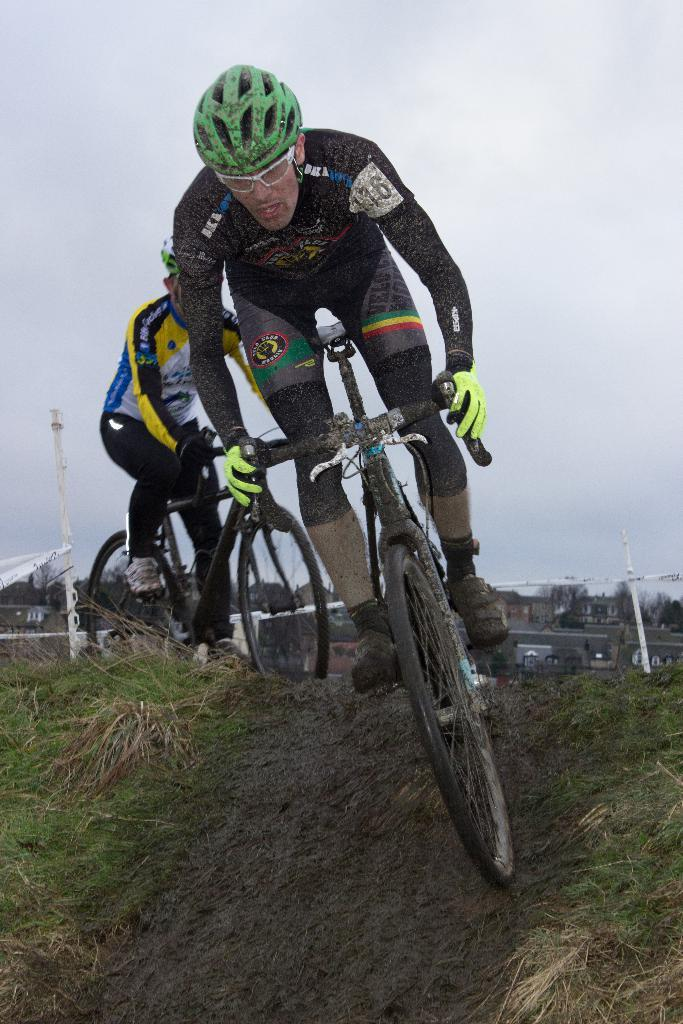How many people are in the image? There are two people in the image. What are the two people doing in the image? The two people are riding bicycles. What can be seen in the background of the image? The background of the image is the sky. What type of chair can be seen in the image? There is no chair present in the image. What hope does the image convey? The image does not convey any specific hope or message; it simply shows two people riding bicycles with the sky as the background. 